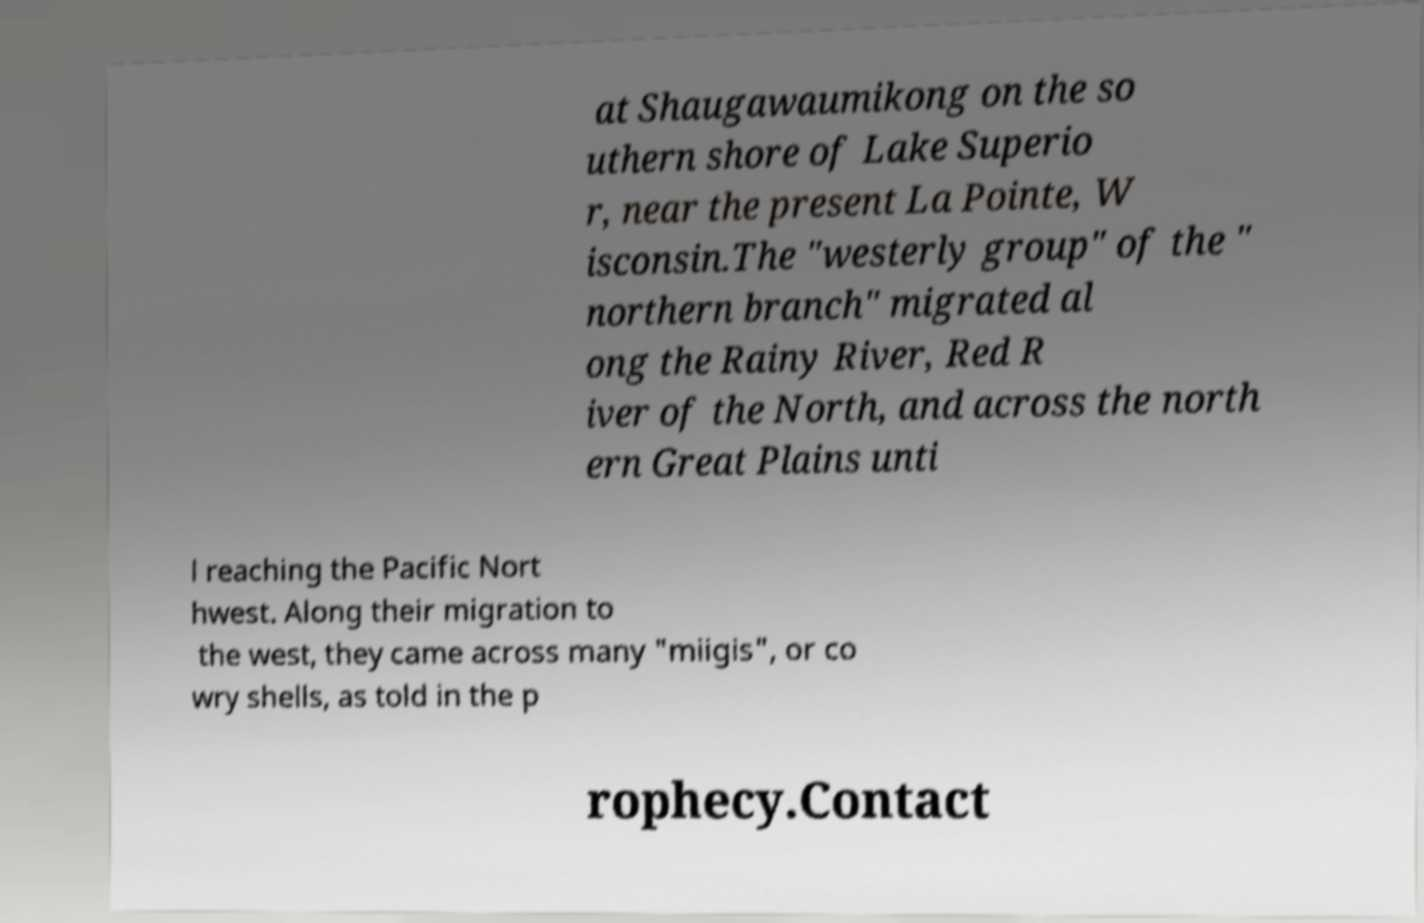For documentation purposes, I need the text within this image transcribed. Could you provide that? at Shaugawaumikong on the so uthern shore of Lake Superio r, near the present La Pointe, W isconsin.The "westerly group" of the " northern branch" migrated al ong the Rainy River, Red R iver of the North, and across the north ern Great Plains unti l reaching the Pacific Nort hwest. Along their migration to the west, they came across many "miigis", or co wry shells, as told in the p rophecy.Contact 